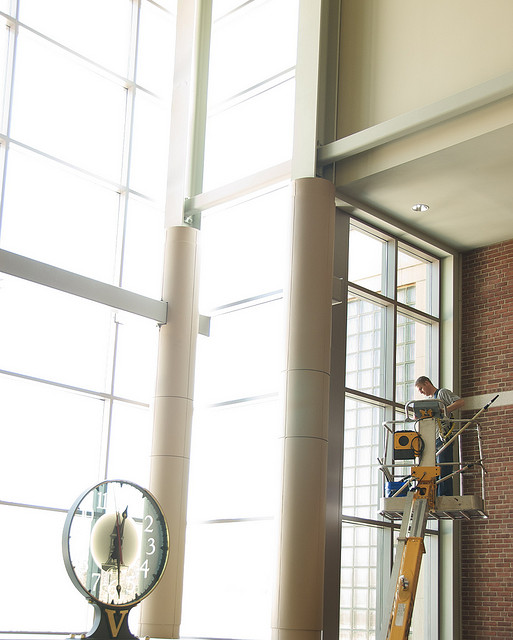Extract all visible text content from this image. 11 2 3 4 7 6 5 